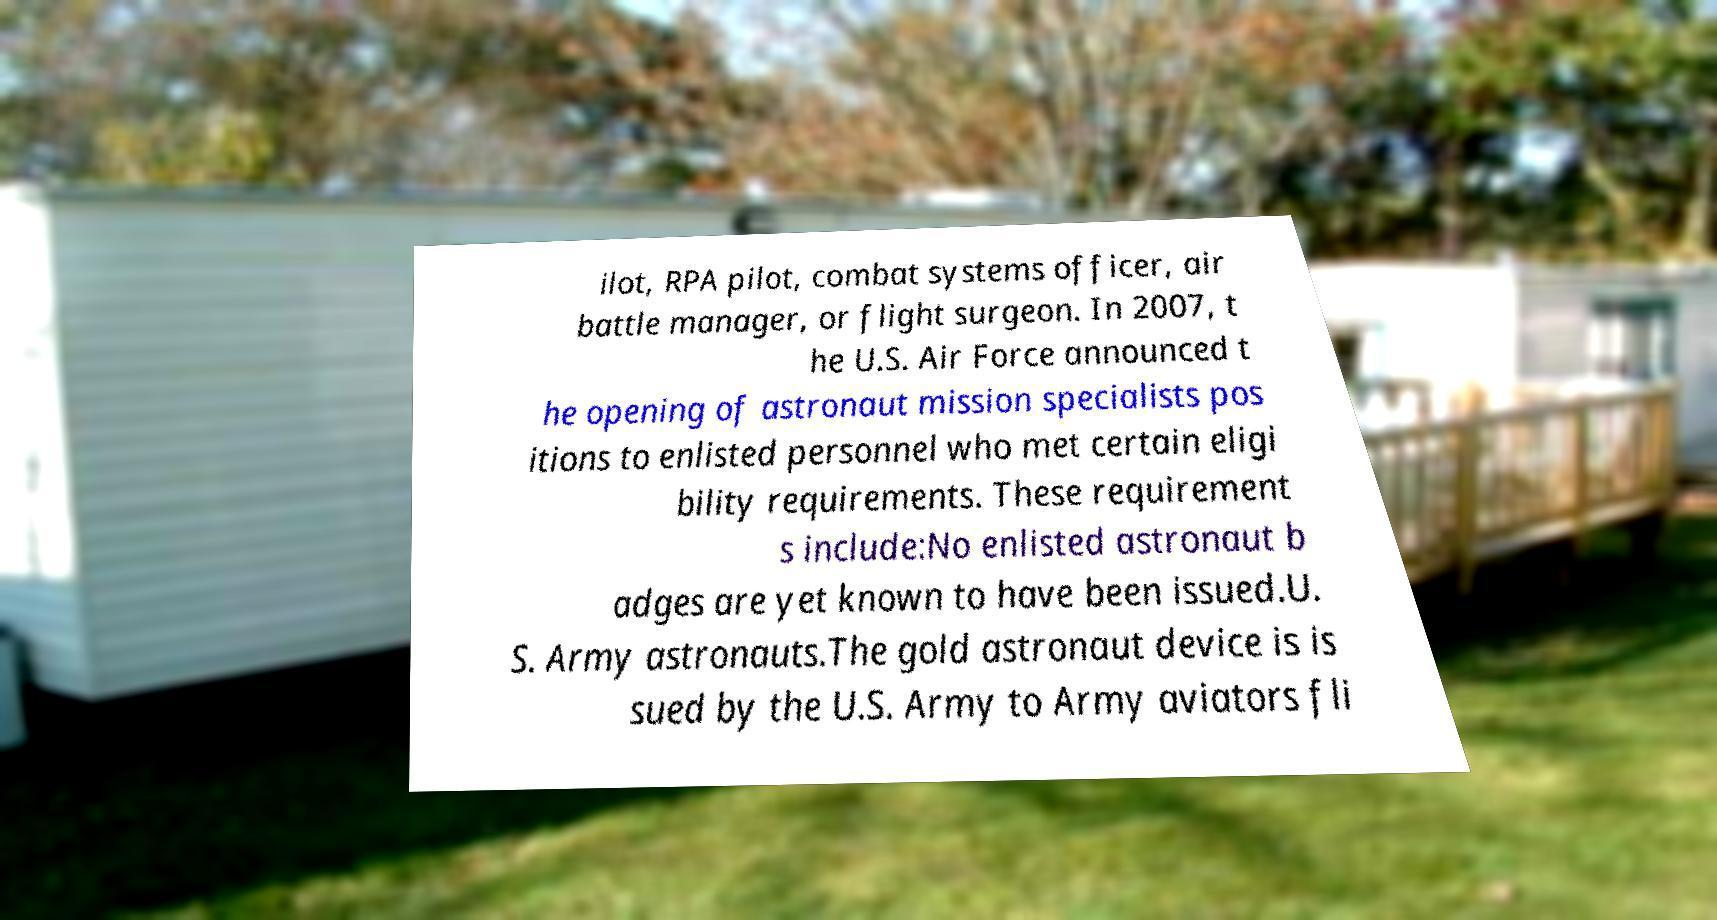Can you read and provide the text displayed in the image?This photo seems to have some interesting text. Can you extract and type it out for me? ilot, RPA pilot, combat systems officer, air battle manager, or flight surgeon. In 2007, t he U.S. Air Force announced t he opening of astronaut mission specialists pos itions to enlisted personnel who met certain eligi bility requirements. These requirement s include:No enlisted astronaut b adges are yet known to have been issued.U. S. Army astronauts.The gold astronaut device is is sued by the U.S. Army to Army aviators fli 